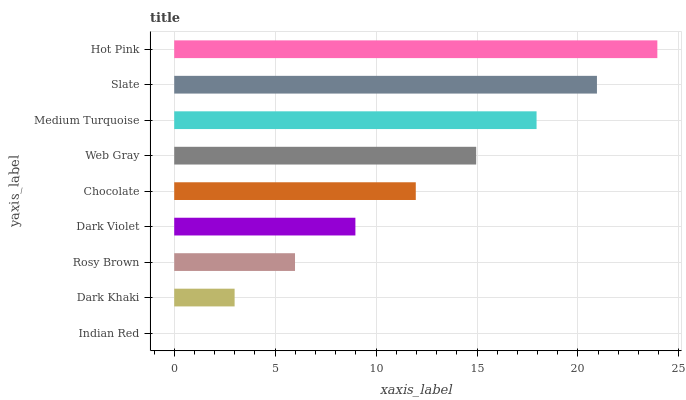Is Indian Red the minimum?
Answer yes or no. Yes. Is Hot Pink the maximum?
Answer yes or no. Yes. Is Dark Khaki the minimum?
Answer yes or no. No. Is Dark Khaki the maximum?
Answer yes or no. No. Is Dark Khaki greater than Indian Red?
Answer yes or no. Yes. Is Indian Red less than Dark Khaki?
Answer yes or no. Yes. Is Indian Red greater than Dark Khaki?
Answer yes or no. No. Is Dark Khaki less than Indian Red?
Answer yes or no. No. Is Chocolate the high median?
Answer yes or no. Yes. Is Chocolate the low median?
Answer yes or no. Yes. Is Indian Red the high median?
Answer yes or no. No. Is Slate the low median?
Answer yes or no. No. 